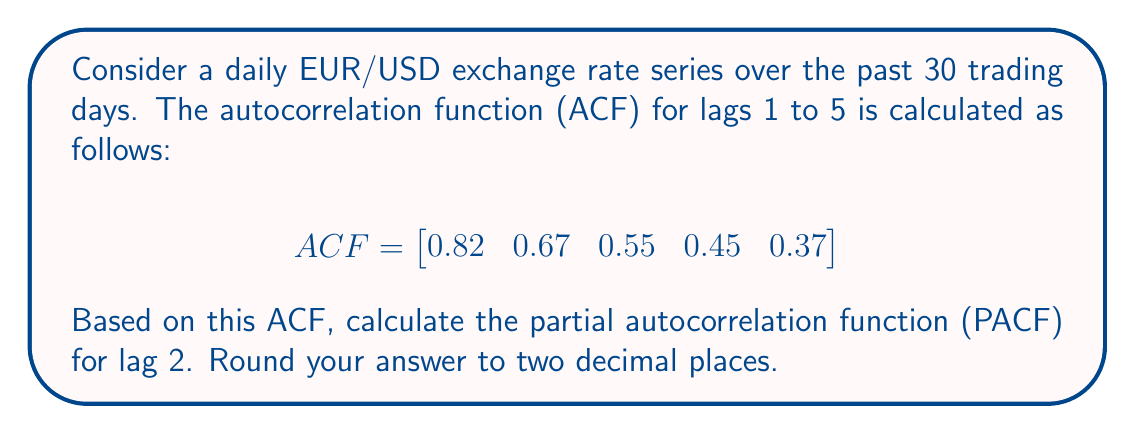Can you solve this math problem? To calculate the partial autocorrelation function (PACF) for lag 2, we need to use the Durbin-Levinson algorithm. This algorithm involves the following steps:

1. Set $\phi_{11} = \rho_1 = 0.82$ (the first ACF value)

2. For lag 2, we use the formula:

   $$ \phi_{22} = \frac{\rho_2 - \phi_{11}\rho_1}{1 - \phi_{11}^2} $$

   Where:
   - $\rho_2$ is the ACF at lag 2 (0.67)
   - $\rho_1$ is the ACF at lag 1 (0.82)
   - $\phi_{11}$ is the PACF at lag 1 (0.82)

3. Substituting the values:

   $$ \phi_{22} = \frac{0.67 - (0.82)(0.82)}{1 - (0.82)^2} $$

4. Simplifying:

   $$ \phi_{22} = \frac{0.67 - 0.6724}{1 - 0.6724} $$
   $$ \phi_{22} = \frac{-0.0024}{0.3276} $$
   $$ \phi_{22} = -0.007326 $$

5. Rounding to two decimal places:

   $$ \phi_{22} \approx -0.01 $$

The negative value indicates a slight negative partial correlation at lag 2, after accounting for the correlation at lag 1.
Answer: $-0.01$ 